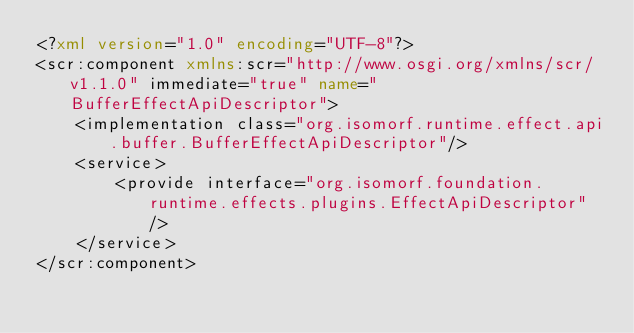Convert code to text. <code><loc_0><loc_0><loc_500><loc_500><_XML_><?xml version="1.0" encoding="UTF-8"?>
<scr:component xmlns:scr="http://www.osgi.org/xmlns/scr/v1.1.0" immediate="true" name="BufferEffectApiDescriptor">
    <implementation class="org.isomorf.runtime.effect.api.buffer.BufferEffectApiDescriptor"/>
	<service>
		<provide interface="org.isomorf.foundation.runtime.effects.plugins.EffectApiDescriptor" />
	</service>
</scr:component>
</code> 